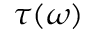<formula> <loc_0><loc_0><loc_500><loc_500>\tau ( \omega )</formula> 